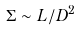Convert formula to latex. <formula><loc_0><loc_0><loc_500><loc_500>\Sigma \sim L / D ^ { 2 }</formula> 